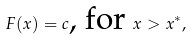<formula> <loc_0><loc_0><loc_500><loc_500>F ( x ) = c \text {, for } x > x ^ { * } ,</formula> 